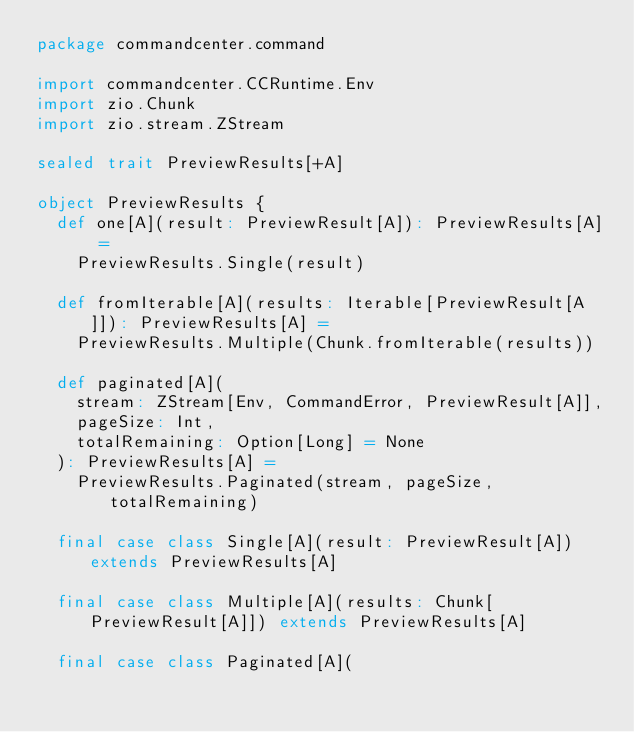Convert code to text. <code><loc_0><loc_0><loc_500><loc_500><_Scala_>package commandcenter.command

import commandcenter.CCRuntime.Env
import zio.Chunk
import zio.stream.ZStream

sealed trait PreviewResults[+A]

object PreviewResults {
  def one[A](result: PreviewResult[A]): PreviewResults[A] =
    PreviewResults.Single(result)

  def fromIterable[A](results: Iterable[PreviewResult[A]]): PreviewResults[A] =
    PreviewResults.Multiple(Chunk.fromIterable(results))

  def paginated[A](
    stream: ZStream[Env, CommandError, PreviewResult[A]],
    pageSize: Int,
    totalRemaining: Option[Long] = None
  ): PreviewResults[A] =
    PreviewResults.Paginated(stream, pageSize, totalRemaining)

  final case class Single[A](result: PreviewResult[A]) extends PreviewResults[A]

  final case class Multiple[A](results: Chunk[PreviewResult[A]]) extends PreviewResults[A]

  final case class Paginated[A](</code> 